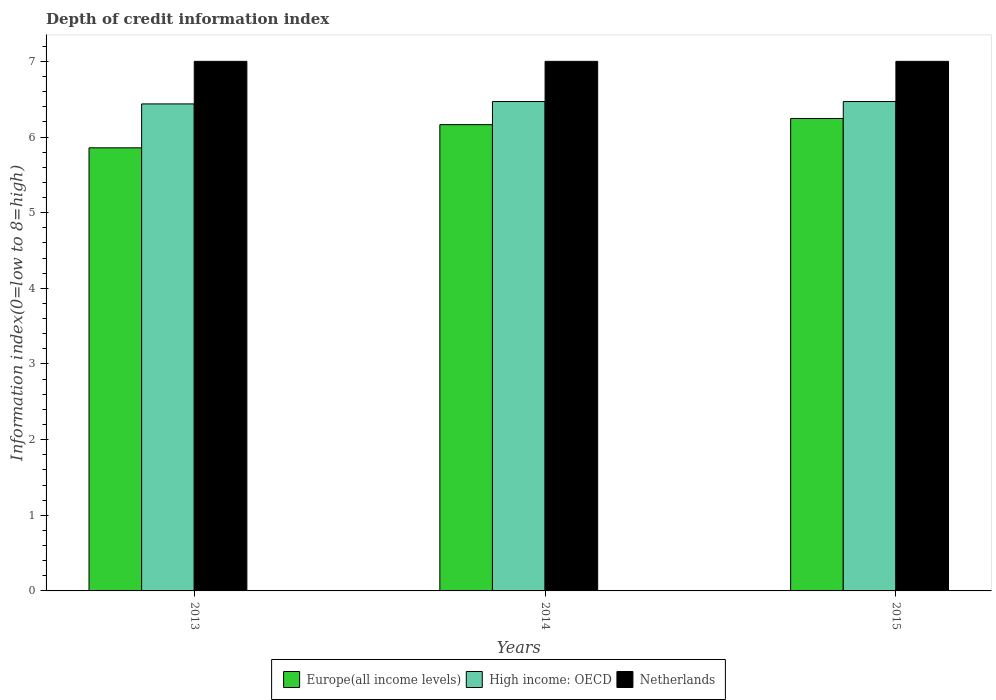How many different coloured bars are there?
Provide a short and direct response. 3. Are the number of bars per tick equal to the number of legend labels?
Offer a very short reply. Yes. Are the number of bars on each tick of the X-axis equal?
Offer a very short reply. Yes. How many bars are there on the 2nd tick from the left?
Your answer should be compact. 3. What is the label of the 1st group of bars from the left?
Offer a very short reply. 2013. In how many cases, is the number of bars for a given year not equal to the number of legend labels?
Your answer should be compact. 0. What is the information index in High income: OECD in 2015?
Ensure brevity in your answer.  6.47. Across all years, what is the maximum information index in High income: OECD?
Give a very brief answer. 6.47. Across all years, what is the minimum information index in Europe(all income levels)?
Make the answer very short. 5.86. In which year was the information index in Netherlands minimum?
Your answer should be compact. 2013. What is the total information index in Netherlands in the graph?
Your response must be concise. 21. What is the difference between the information index in Europe(all income levels) in 2013 and that in 2015?
Provide a succinct answer. -0.39. What is the difference between the information index in Netherlands in 2015 and the information index in High income: OECD in 2014?
Provide a succinct answer. 0.53. In the year 2015, what is the difference between the information index in Netherlands and information index in High income: OECD?
Offer a terse response. 0.53. What is the ratio of the information index in High income: OECD in 2013 to that in 2015?
Your answer should be very brief. 1. Is the information index in High income: OECD in 2013 less than that in 2015?
Provide a short and direct response. Yes. What is the difference between the highest and the second highest information index in Netherlands?
Give a very brief answer. 0. What is the difference between the highest and the lowest information index in High income: OECD?
Give a very brief answer. 0.03. In how many years, is the information index in Netherlands greater than the average information index in Netherlands taken over all years?
Offer a terse response. 0. Is the sum of the information index in Europe(all income levels) in 2014 and 2015 greater than the maximum information index in Netherlands across all years?
Offer a very short reply. Yes. What does the 3rd bar from the left in 2015 represents?
Offer a very short reply. Netherlands. What does the 3rd bar from the right in 2013 represents?
Keep it short and to the point. Europe(all income levels). How many bars are there?
Provide a short and direct response. 9. Are all the bars in the graph horizontal?
Your answer should be very brief. No. What is the difference between two consecutive major ticks on the Y-axis?
Your answer should be very brief. 1. Does the graph contain any zero values?
Ensure brevity in your answer.  No. Where does the legend appear in the graph?
Offer a terse response. Bottom center. How many legend labels are there?
Give a very brief answer. 3. What is the title of the graph?
Provide a succinct answer. Depth of credit information index. Does "Upper middle income" appear as one of the legend labels in the graph?
Your answer should be compact. No. What is the label or title of the X-axis?
Provide a succinct answer. Years. What is the label or title of the Y-axis?
Provide a succinct answer. Information index(0=low to 8=high). What is the Information index(0=low to 8=high) in Europe(all income levels) in 2013?
Offer a terse response. 5.86. What is the Information index(0=low to 8=high) in High income: OECD in 2013?
Offer a very short reply. 6.44. What is the Information index(0=low to 8=high) of Europe(all income levels) in 2014?
Ensure brevity in your answer.  6.16. What is the Information index(0=low to 8=high) of High income: OECD in 2014?
Your answer should be very brief. 6.47. What is the Information index(0=low to 8=high) in Netherlands in 2014?
Your answer should be compact. 7. What is the Information index(0=low to 8=high) of Europe(all income levels) in 2015?
Your answer should be very brief. 6.24. What is the Information index(0=low to 8=high) in High income: OECD in 2015?
Offer a terse response. 6.47. Across all years, what is the maximum Information index(0=low to 8=high) in Europe(all income levels)?
Your answer should be very brief. 6.24. Across all years, what is the maximum Information index(0=low to 8=high) of High income: OECD?
Provide a succinct answer. 6.47. Across all years, what is the maximum Information index(0=low to 8=high) in Netherlands?
Make the answer very short. 7. Across all years, what is the minimum Information index(0=low to 8=high) in Europe(all income levels)?
Keep it short and to the point. 5.86. Across all years, what is the minimum Information index(0=low to 8=high) in High income: OECD?
Make the answer very short. 6.44. Across all years, what is the minimum Information index(0=low to 8=high) of Netherlands?
Offer a very short reply. 7. What is the total Information index(0=low to 8=high) in Europe(all income levels) in the graph?
Provide a succinct answer. 18.27. What is the total Information index(0=low to 8=high) of High income: OECD in the graph?
Provide a succinct answer. 19.38. What is the total Information index(0=low to 8=high) in Netherlands in the graph?
Give a very brief answer. 21. What is the difference between the Information index(0=low to 8=high) of Europe(all income levels) in 2013 and that in 2014?
Provide a short and direct response. -0.31. What is the difference between the Information index(0=low to 8=high) of High income: OECD in 2013 and that in 2014?
Provide a succinct answer. -0.03. What is the difference between the Information index(0=low to 8=high) of Europe(all income levels) in 2013 and that in 2015?
Your answer should be very brief. -0.39. What is the difference between the Information index(0=low to 8=high) in High income: OECD in 2013 and that in 2015?
Provide a succinct answer. -0.03. What is the difference between the Information index(0=low to 8=high) in Europe(all income levels) in 2014 and that in 2015?
Offer a terse response. -0.08. What is the difference between the Information index(0=low to 8=high) of Europe(all income levels) in 2013 and the Information index(0=low to 8=high) of High income: OECD in 2014?
Offer a terse response. -0.61. What is the difference between the Information index(0=low to 8=high) in Europe(all income levels) in 2013 and the Information index(0=low to 8=high) in Netherlands in 2014?
Your response must be concise. -1.14. What is the difference between the Information index(0=low to 8=high) in High income: OECD in 2013 and the Information index(0=low to 8=high) in Netherlands in 2014?
Make the answer very short. -0.56. What is the difference between the Information index(0=low to 8=high) in Europe(all income levels) in 2013 and the Information index(0=low to 8=high) in High income: OECD in 2015?
Your answer should be compact. -0.61. What is the difference between the Information index(0=low to 8=high) of Europe(all income levels) in 2013 and the Information index(0=low to 8=high) of Netherlands in 2015?
Give a very brief answer. -1.14. What is the difference between the Information index(0=low to 8=high) of High income: OECD in 2013 and the Information index(0=low to 8=high) of Netherlands in 2015?
Provide a succinct answer. -0.56. What is the difference between the Information index(0=low to 8=high) in Europe(all income levels) in 2014 and the Information index(0=low to 8=high) in High income: OECD in 2015?
Make the answer very short. -0.31. What is the difference between the Information index(0=low to 8=high) of Europe(all income levels) in 2014 and the Information index(0=low to 8=high) of Netherlands in 2015?
Provide a succinct answer. -0.84. What is the difference between the Information index(0=low to 8=high) of High income: OECD in 2014 and the Information index(0=low to 8=high) of Netherlands in 2015?
Your answer should be very brief. -0.53. What is the average Information index(0=low to 8=high) in Europe(all income levels) per year?
Give a very brief answer. 6.09. What is the average Information index(0=low to 8=high) in High income: OECD per year?
Offer a very short reply. 6.46. In the year 2013, what is the difference between the Information index(0=low to 8=high) in Europe(all income levels) and Information index(0=low to 8=high) in High income: OECD?
Your answer should be compact. -0.58. In the year 2013, what is the difference between the Information index(0=low to 8=high) in Europe(all income levels) and Information index(0=low to 8=high) in Netherlands?
Provide a succinct answer. -1.14. In the year 2013, what is the difference between the Information index(0=low to 8=high) in High income: OECD and Information index(0=low to 8=high) in Netherlands?
Ensure brevity in your answer.  -0.56. In the year 2014, what is the difference between the Information index(0=low to 8=high) of Europe(all income levels) and Information index(0=low to 8=high) of High income: OECD?
Provide a succinct answer. -0.31. In the year 2014, what is the difference between the Information index(0=low to 8=high) of Europe(all income levels) and Information index(0=low to 8=high) of Netherlands?
Provide a short and direct response. -0.84. In the year 2014, what is the difference between the Information index(0=low to 8=high) of High income: OECD and Information index(0=low to 8=high) of Netherlands?
Offer a terse response. -0.53. In the year 2015, what is the difference between the Information index(0=low to 8=high) of Europe(all income levels) and Information index(0=low to 8=high) of High income: OECD?
Provide a short and direct response. -0.22. In the year 2015, what is the difference between the Information index(0=low to 8=high) of Europe(all income levels) and Information index(0=low to 8=high) of Netherlands?
Offer a very short reply. -0.76. In the year 2015, what is the difference between the Information index(0=low to 8=high) of High income: OECD and Information index(0=low to 8=high) of Netherlands?
Your answer should be very brief. -0.53. What is the ratio of the Information index(0=low to 8=high) in Europe(all income levels) in 2013 to that in 2014?
Keep it short and to the point. 0.95. What is the ratio of the Information index(0=low to 8=high) of High income: OECD in 2013 to that in 2014?
Keep it short and to the point. 1. What is the ratio of the Information index(0=low to 8=high) in Europe(all income levels) in 2013 to that in 2015?
Your answer should be very brief. 0.94. What is the ratio of the Information index(0=low to 8=high) in High income: OECD in 2013 to that in 2015?
Make the answer very short. 1. What is the ratio of the Information index(0=low to 8=high) in Europe(all income levels) in 2014 to that in 2015?
Keep it short and to the point. 0.99. What is the ratio of the Information index(0=low to 8=high) of High income: OECD in 2014 to that in 2015?
Provide a short and direct response. 1. What is the ratio of the Information index(0=low to 8=high) of Netherlands in 2014 to that in 2015?
Provide a short and direct response. 1. What is the difference between the highest and the second highest Information index(0=low to 8=high) of Europe(all income levels)?
Your response must be concise. 0.08. What is the difference between the highest and the second highest Information index(0=low to 8=high) of High income: OECD?
Offer a terse response. 0. What is the difference between the highest and the second highest Information index(0=low to 8=high) of Netherlands?
Provide a succinct answer. 0. What is the difference between the highest and the lowest Information index(0=low to 8=high) in Europe(all income levels)?
Provide a short and direct response. 0.39. What is the difference between the highest and the lowest Information index(0=low to 8=high) in High income: OECD?
Your answer should be very brief. 0.03. What is the difference between the highest and the lowest Information index(0=low to 8=high) of Netherlands?
Your answer should be very brief. 0. 